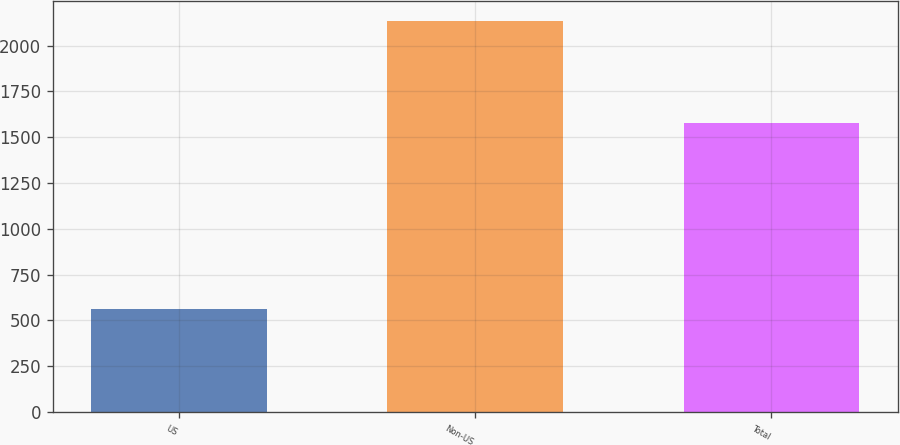Convert chart. <chart><loc_0><loc_0><loc_500><loc_500><bar_chart><fcel>US<fcel>Non-US<fcel>Total<nl><fcel>560<fcel>2136<fcel>1576<nl></chart> 